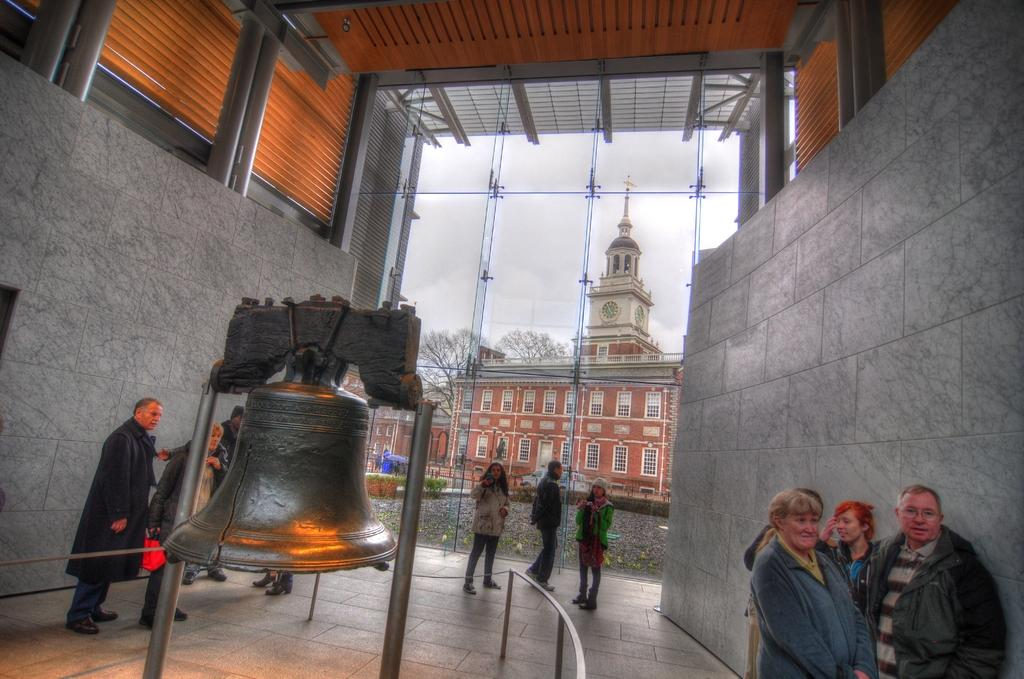What type of structure is visible in the image? There is a building in the image. What other natural elements can be seen in the image? There are trees in the image. What object is present that could be used for signaling or attracting attention? There is a bell in the image. Can you describe the people in the image? There are people standing in the image. What type of spoon is being used by the people in the image? There is no spoon present in the image. How does the power source for the building look like in the image? The image does not show any details about the power source for the building. 